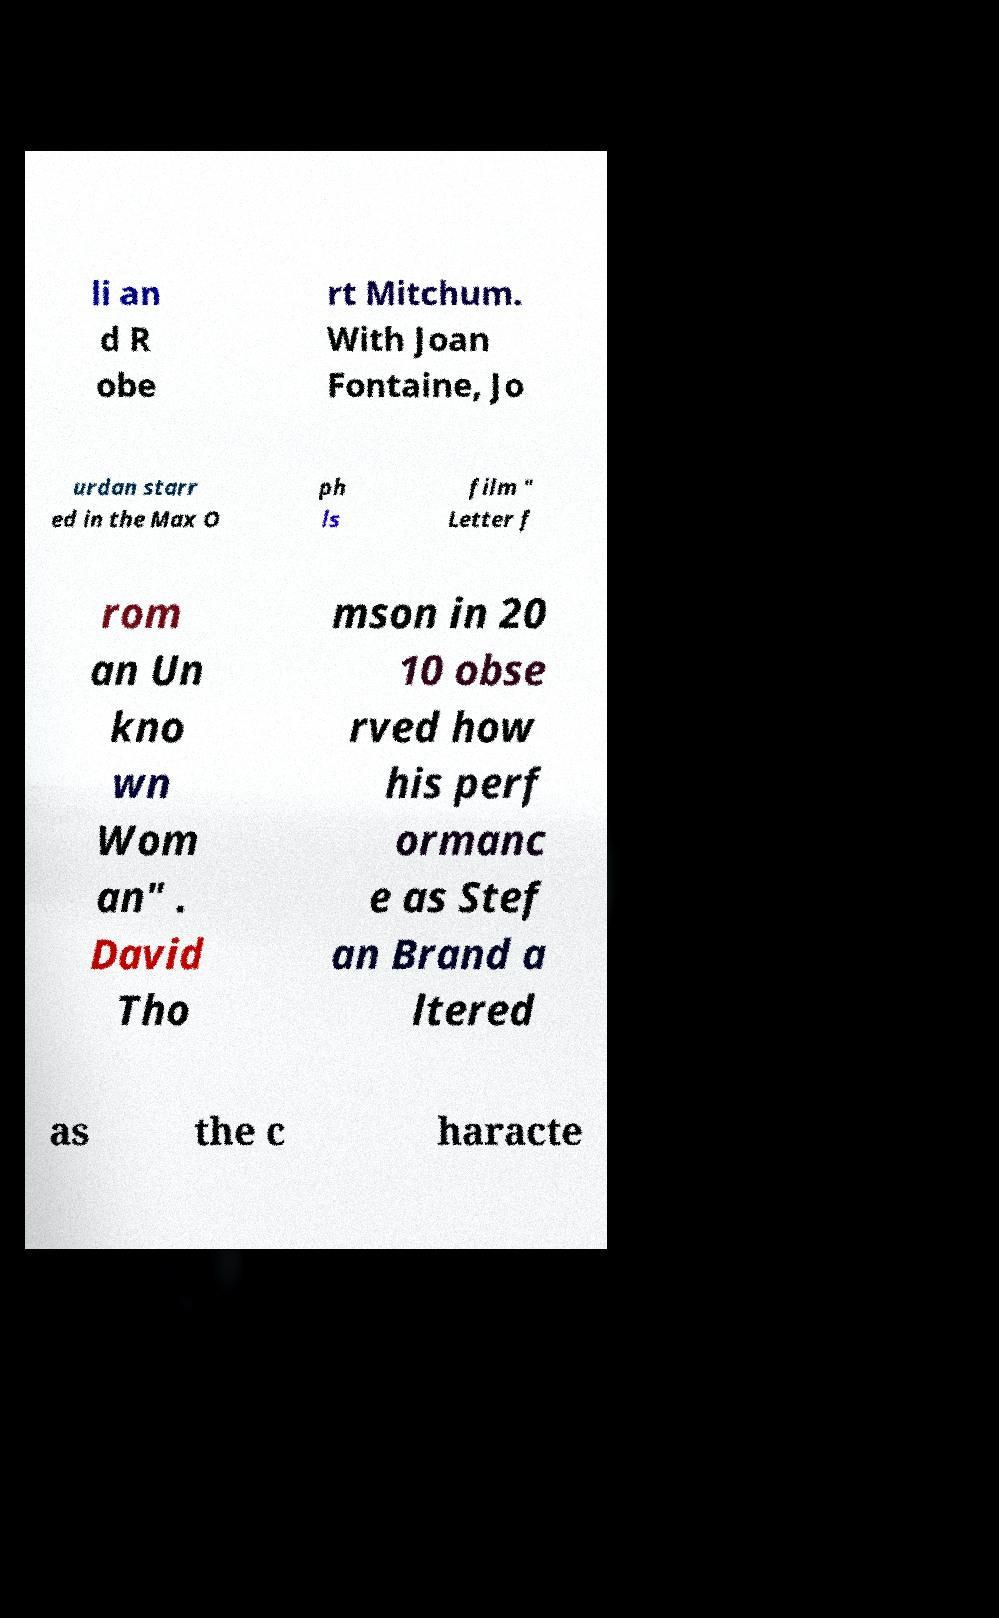Can you read and provide the text displayed in the image?This photo seems to have some interesting text. Can you extract and type it out for me? li an d R obe rt Mitchum. With Joan Fontaine, Jo urdan starr ed in the Max O ph ls film " Letter f rom an Un kno wn Wom an" . David Tho mson in 20 10 obse rved how his perf ormanc e as Stef an Brand a ltered as the c haracte 